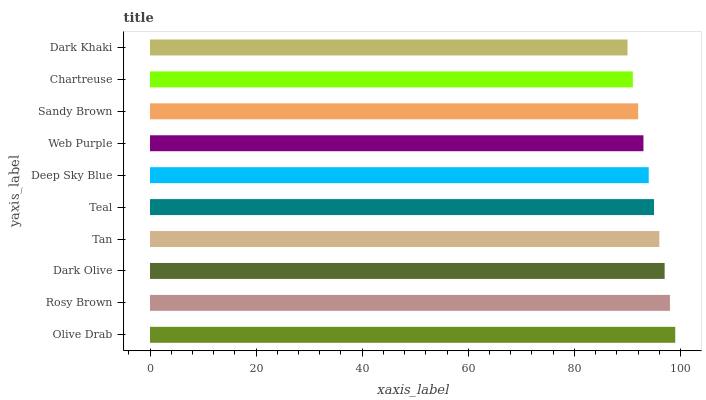Is Dark Khaki the minimum?
Answer yes or no. Yes. Is Olive Drab the maximum?
Answer yes or no. Yes. Is Rosy Brown the minimum?
Answer yes or no. No. Is Rosy Brown the maximum?
Answer yes or no. No. Is Olive Drab greater than Rosy Brown?
Answer yes or no. Yes. Is Rosy Brown less than Olive Drab?
Answer yes or no. Yes. Is Rosy Brown greater than Olive Drab?
Answer yes or no. No. Is Olive Drab less than Rosy Brown?
Answer yes or no. No. Is Teal the high median?
Answer yes or no. Yes. Is Deep Sky Blue the low median?
Answer yes or no. Yes. Is Chartreuse the high median?
Answer yes or no. No. Is Dark Olive the low median?
Answer yes or no. No. 